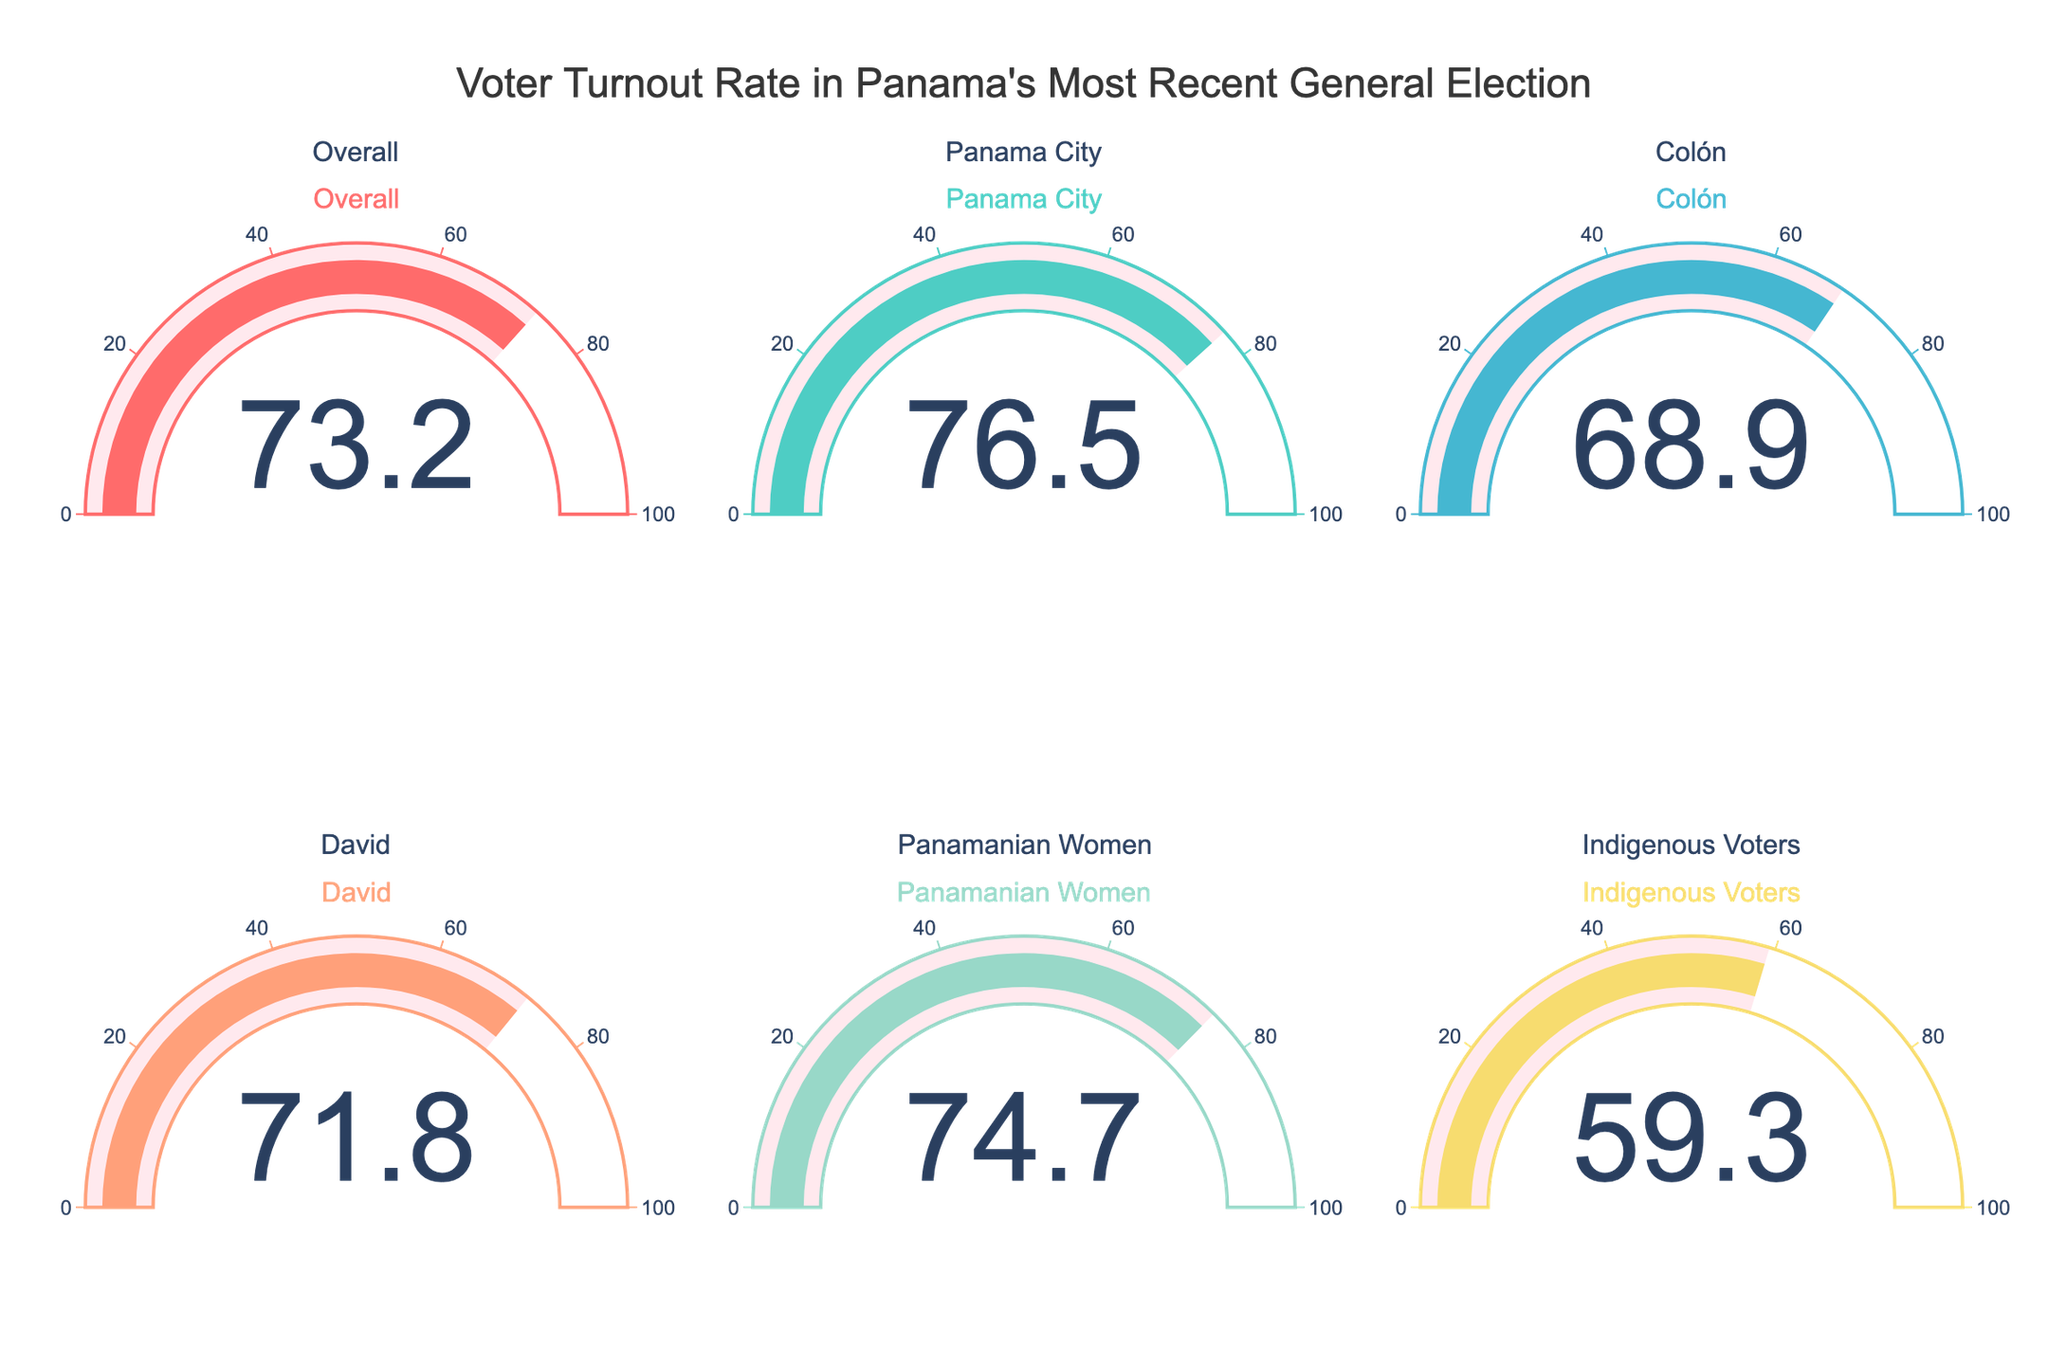What's the overall voter turnout rate in the most recent Panamanian general election? To find the overall voter turnout rate, look at the gauge that specifically displays the value for 'Overall.'
Answer: 73.2 Which demographic had the highest voter turnout rate? Compare all the values shown in the gauges. The highest numeric value will indicate the demographic with the highest turnout rate.
Answer: Panama City What is the difference in the voter turnout rates between Panama City and Colón? Look at the values for Panama City and Colón. Subtract the turnout rate of Colón from that of Panama City to find the difference.
Answer: 7.6 Which demographic had the lowest voter turnout rate? Identify the lowest numeric value displayed in the gauges to determine which demographic had the lowest turnout rate.
Answer: Indigenous Voters What is the average voter turnout rate among Panama City, Colón, and David? Add the turnout rates for Panama City, Colón, and David, then divide by 3 to get the average.
Answer: 72.4 Is the turnout rate for Panamanian Women higher than the overall turnout rate? Compare the turnout rate for Panamanian Women to the overall turnout rate. If the Panamanian Women's rate is higher, the answer is yes.
Answer: Yes How much lower is the voter turnout rate for Indigenous Voters compared to the overall voter turnout rate? Subtract the turnout rate of Indigenous Voters from the overall turnout rate.
Answer: 13.9 What is the median voter turnout rate among all the demographics displayed? List the voter turnout rates in numerical order and find the middle value. If there's an even number of values, calculate the average of the two middle numbers.
Answer: 72.5 How does the voter turnout rate for David compare to that of Panamanian Women? Compare the values for David and Panamanian Women. Determine if David's turnout rate is lower, higher, or equal.
Answer: Lower Are there more demographics with a turnout rate above or below the overall average? Calculate the overall average turnout rate, then count how many demographics are above and below this average. Since the figure shows a limited number of groups, manual comparison of each group with the average is feasible.
Answer: Above 